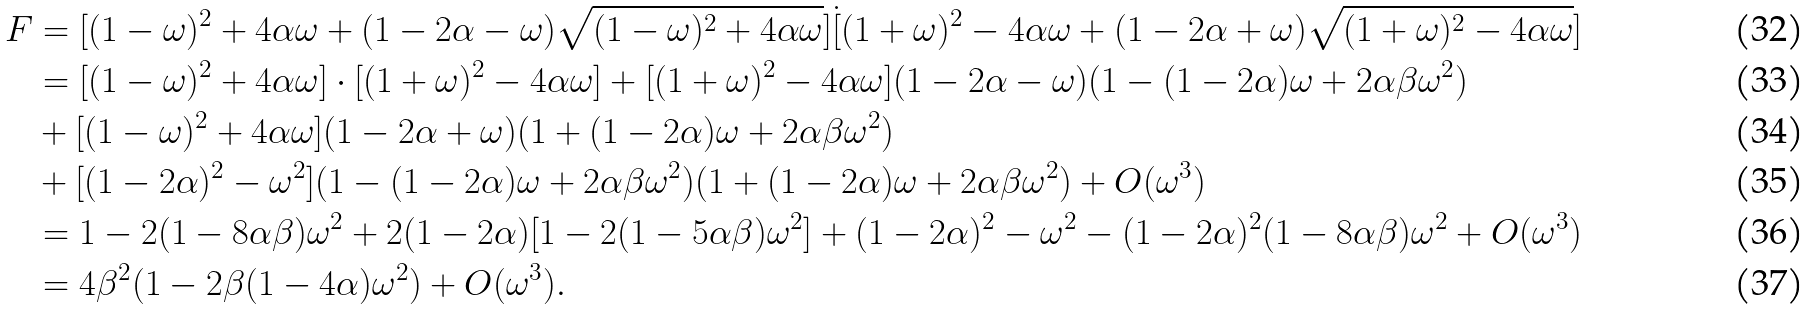<formula> <loc_0><loc_0><loc_500><loc_500>F & = [ ( 1 - \omega ) ^ { 2 } + 4 \alpha \omega + ( 1 - 2 \alpha - \omega ) \sqrt { ( 1 - \omega ) ^ { 2 } + 4 \alpha \omega } ] \dot { [ } ( 1 + \omega ) ^ { 2 } - 4 \alpha \omega + ( 1 - 2 \alpha + \omega ) \sqrt { ( 1 + \omega ) ^ { 2 } - 4 \alpha \omega } ] \\ & = [ ( 1 - \omega ) ^ { 2 } + 4 \alpha \omega ] \cdot [ ( 1 + \omega ) ^ { 2 } - 4 \alpha \omega ] + [ ( 1 + \omega ) ^ { 2 } - 4 \alpha \omega ] ( 1 - 2 \alpha - \omega ) ( 1 - ( 1 - 2 \alpha ) \omega + 2 \alpha \beta \omega ^ { 2 } ) \\ & + [ ( 1 - \omega ) ^ { 2 } + 4 \alpha \omega ] ( 1 - 2 \alpha + \omega ) ( 1 + ( 1 - 2 \alpha ) \omega + 2 \alpha \beta \omega ^ { 2 } ) \\ & + [ ( 1 - 2 \alpha ) ^ { 2 } - \omega ^ { 2 } ] ( 1 - ( 1 - 2 \alpha ) \omega + 2 \alpha \beta \omega ^ { 2 } ) ( 1 + ( 1 - 2 \alpha ) \omega + 2 \alpha \beta \omega ^ { 2 } ) + O ( \omega ^ { 3 } ) \\ & = 1 - 2 ( 1 - 8 \alpha \beta ) \omega ^ { 2 } + 2 ( 1 - 2 \alpha ) [ 1 - 2 ( 1 - 5 \alpha \beta ) \omega ^ { 2 } ] + ( 1 - 2 \alpha ) ^ { 2 } - \omega ^ { 2 } - ( 1 - 2 \alpha ) ^ { 2 } ( 1 - 8 \alpha \beta ) \omega ^ { 2 } + O ( \omega ^ { 3 } ) \\ & = 4 \beta ^ { 2 } ( 1 - 2 \beta ( 1 - 4 \alpha ) \omega ^ { 2 } ) + O ( \omega ^ { 3 } ) .</formula> 